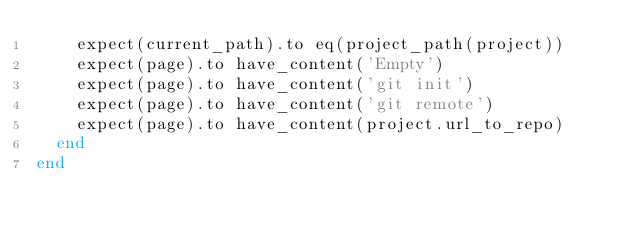<code> <loc_0><loc_0><loc_500><loc_500><_Ruby_>    expect(current_path).to eq(project_path(project))
    expect(page).to have_content('Empty')
    expect(page).to have_content('git init')
    expect(page).to have_content('git remote')
    expect(page).to have_content(project.url_to_repo)
  end
end
</code> 